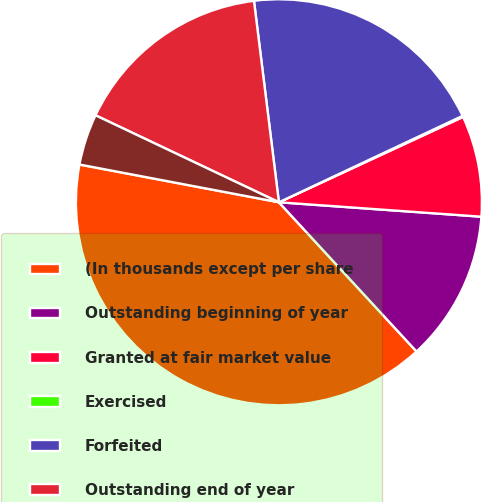Convert chart. <chart><loc_0><loc_0><loc_500><loc_500><pie_chart><fcel>(In thousands except per share<fcel>Outstanding beginning of year<fcel>Granted at fair market value<fcel>Exercised<fcel>Forfeited<fcel>Outstanding end of year<fcel>Options exercisable end of<nl><fcel>39.83%<fcel>12.01%<fcel>8.04%<fcel>0.09%<fcel>19.96%<fcel>15.99%<fcel>4.07%<nl></chart> 